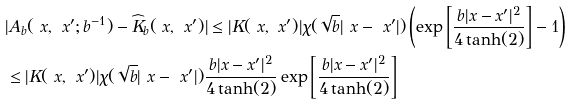<formula> <loc_0><loc_0><loc_500><loc_500>& | A _ { b } ( \ x , \ x ^ { \prime } ; b ^ { - 1 } ) - \widehat { K } _ { b } ( \ x , \ x ^ { \prime } ) | \leq | K ( \ x , \ x ^ { \prime } ) | \chi ( \sqrt { b } | \ x - \ x ^ { \prime } | ) \left ( \exp { \left [ \frac { b | { x } - { x } ^ { \prime } | ^ { 2 } } { 4 \tanh ( 2 ) } \right ] } - 1 \right ) \\ & \leq | K ( \ x , \ x ^ { \prime } ) | \chi ( \sqrt { b } | \ x - \ x ^ { \prime } | ) \frac { b | { x } - { x } ^ { \prime } | ^ { 2 } } { 4 \tanh ( 2 ) } \exp { \left [ \frac { b | { x } - { x } ^ { \prime } | ^ { 2 } } { 4 \tanh ( 2 ) } \right ] }</formula> 